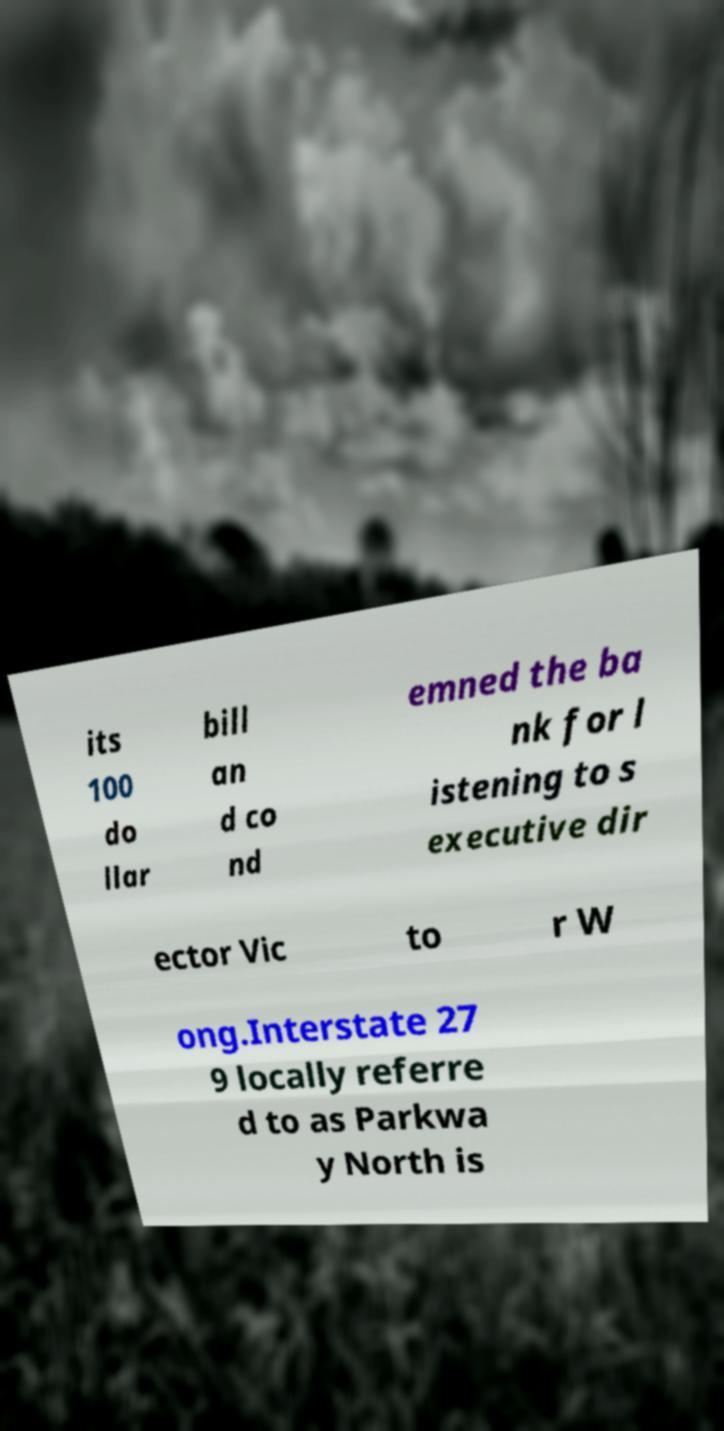Can you accurately transcribe the text from the provided image for me? its 100 do llar bill an d co nd emned the ba nk for l istening to s executive dir ector Vic to r W ong.Interstate 27 9 locally referre d to as Parkwa y North is 